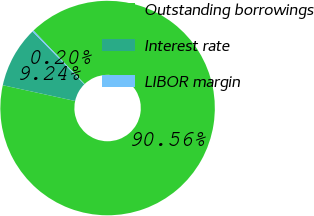Convert chart. <chart><loc_0><loc_0><loc_500><loc_500><pie_chart><fcel>Outstanding borrowings<fcel>Interest rate<fcel>LIBOR margin<nl><fcel>90.56%<fcel>9.24%<fcel>0.2%<nl></chart> 